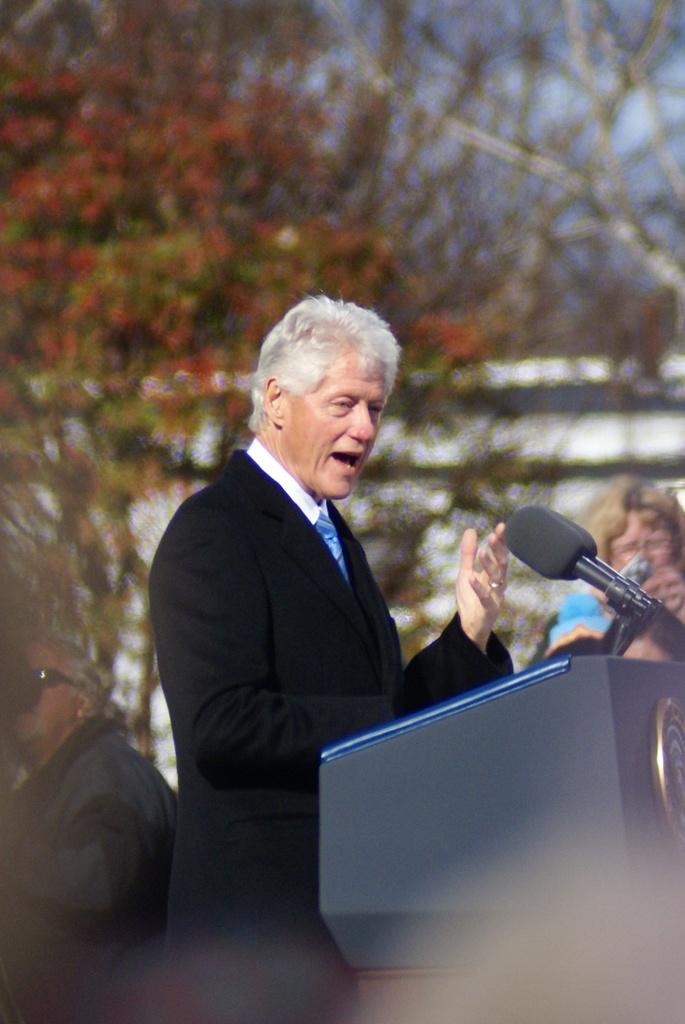What is the man in the image doing? The man is standing at the podium. What is on the podium with the man? There is a microphone on the podium with the man. What can be seen in the background of the image? There are people, trees, an object, and clouds in the sky in the background of the image. What force is being applied to the sail in the image? There is no sail present in the image, so no force can be applied to it. 